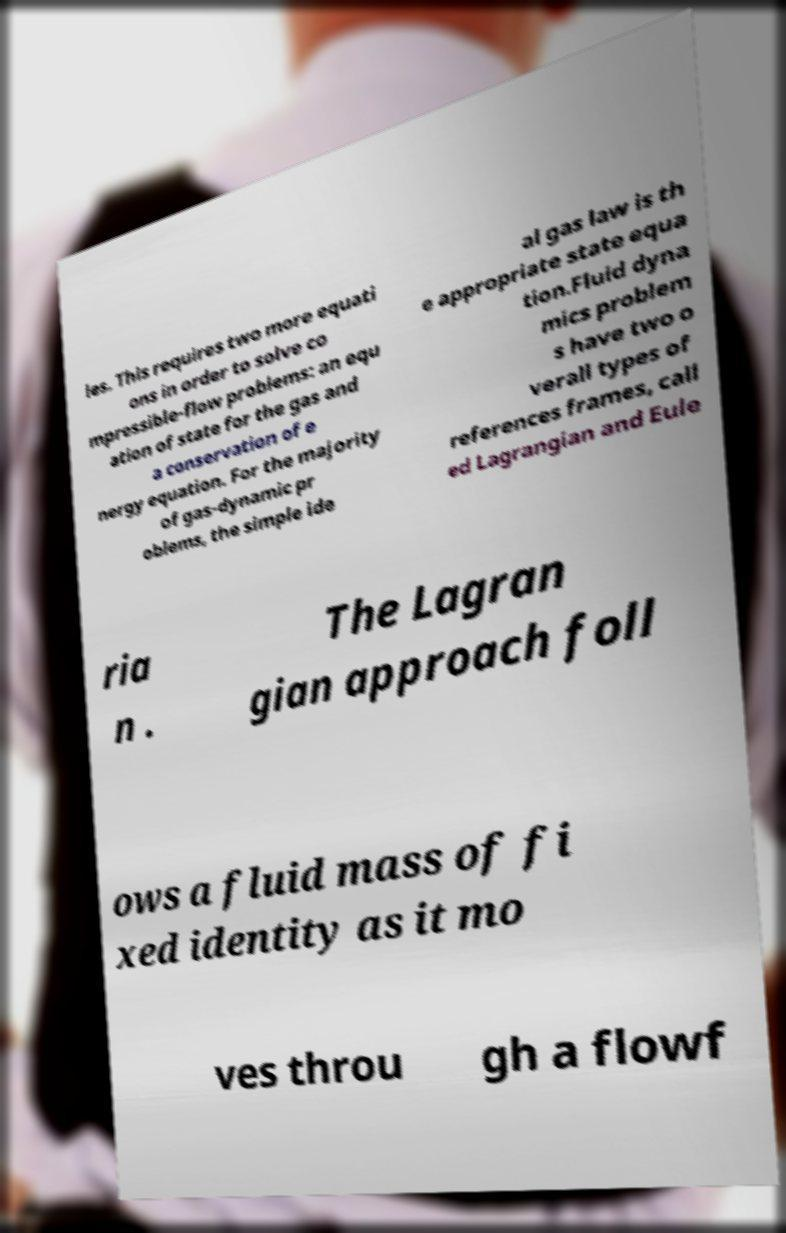Could you extract and type out the text from this image? les. This requires two more equati ons in order to solve co mpressible-flow problems: an equ ation of state for the gas and a conservation of e nergy equation. For the majority of gas-dynamic pr oblems, the simple ide al gas law is th e appropriate state equa tion.Fluid dyna mics problem s have two o verall types of references frames, call ed Lagrangian and Eule ria n . The Lagran gian approach foll ows a fluid mass of fi xed identity as it mo ves throu gh a flowf 